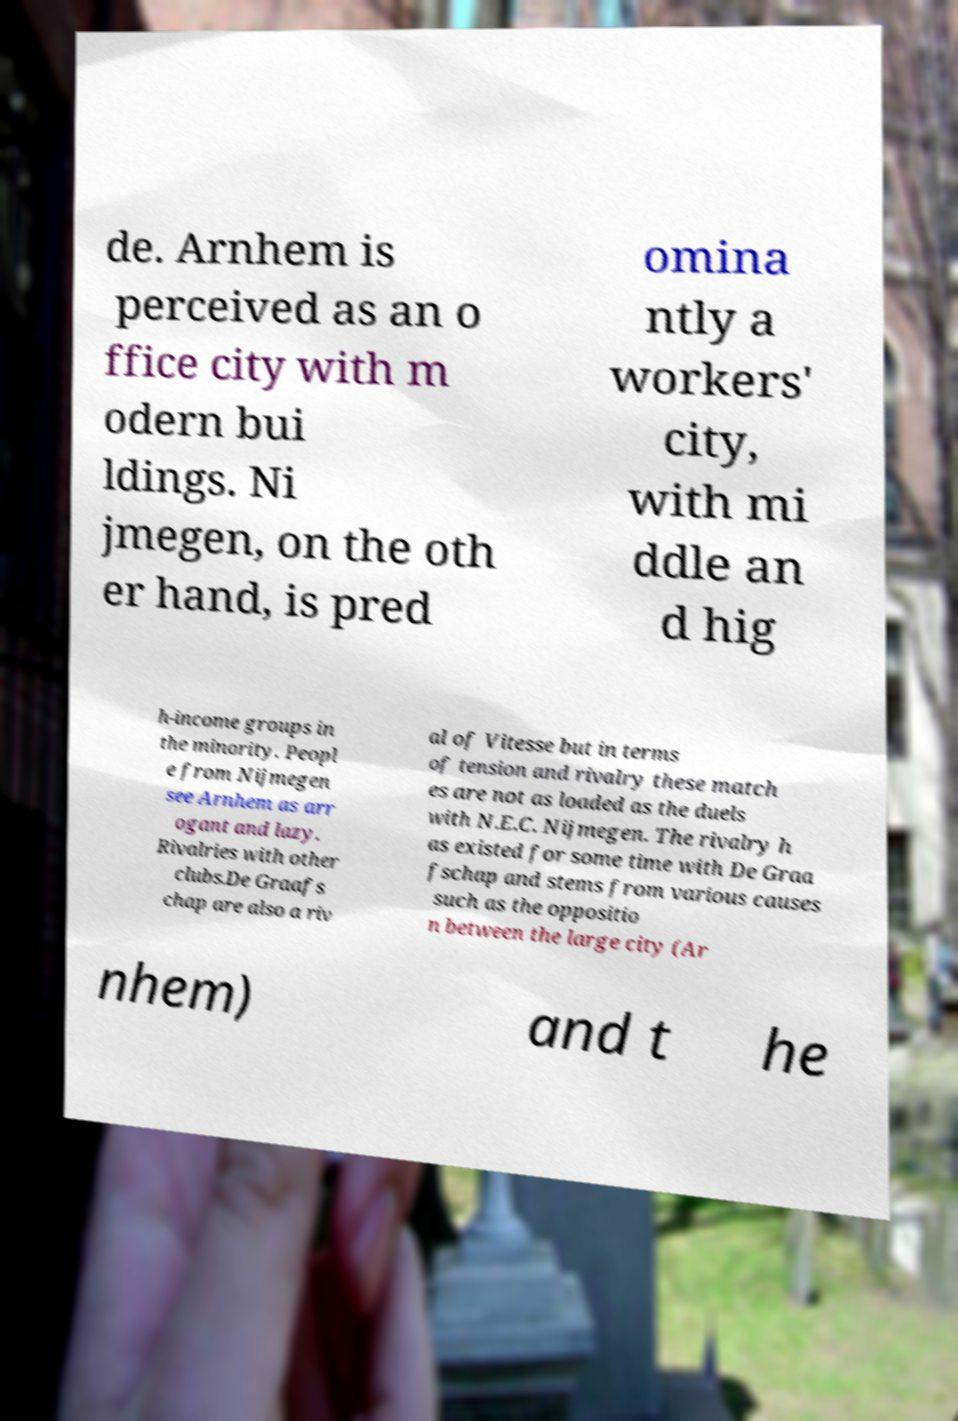Please identify and transcribe the text found in this image. de. Arnhem is perceived as an o ffice city with m odern bui ldings. Ni jmegen, on the oth er hand, is pred omina ntly a workers' city, with mi ddle an d hig h-income groups in the minority. Peopl e from Nijmegen see Arnhem as arr ogant and lazy. Rivalries with other clubs.De Graafs chap are also a riv al of Vitesse but in terms of tension and rivalry these match es are not as loaded as the duels with N.E.C. Nijmegen. The rivalry h as existed for some time with De Graa fschap and stems from various causes such as the oppositio n between the large city (Ar nhem) and t he 